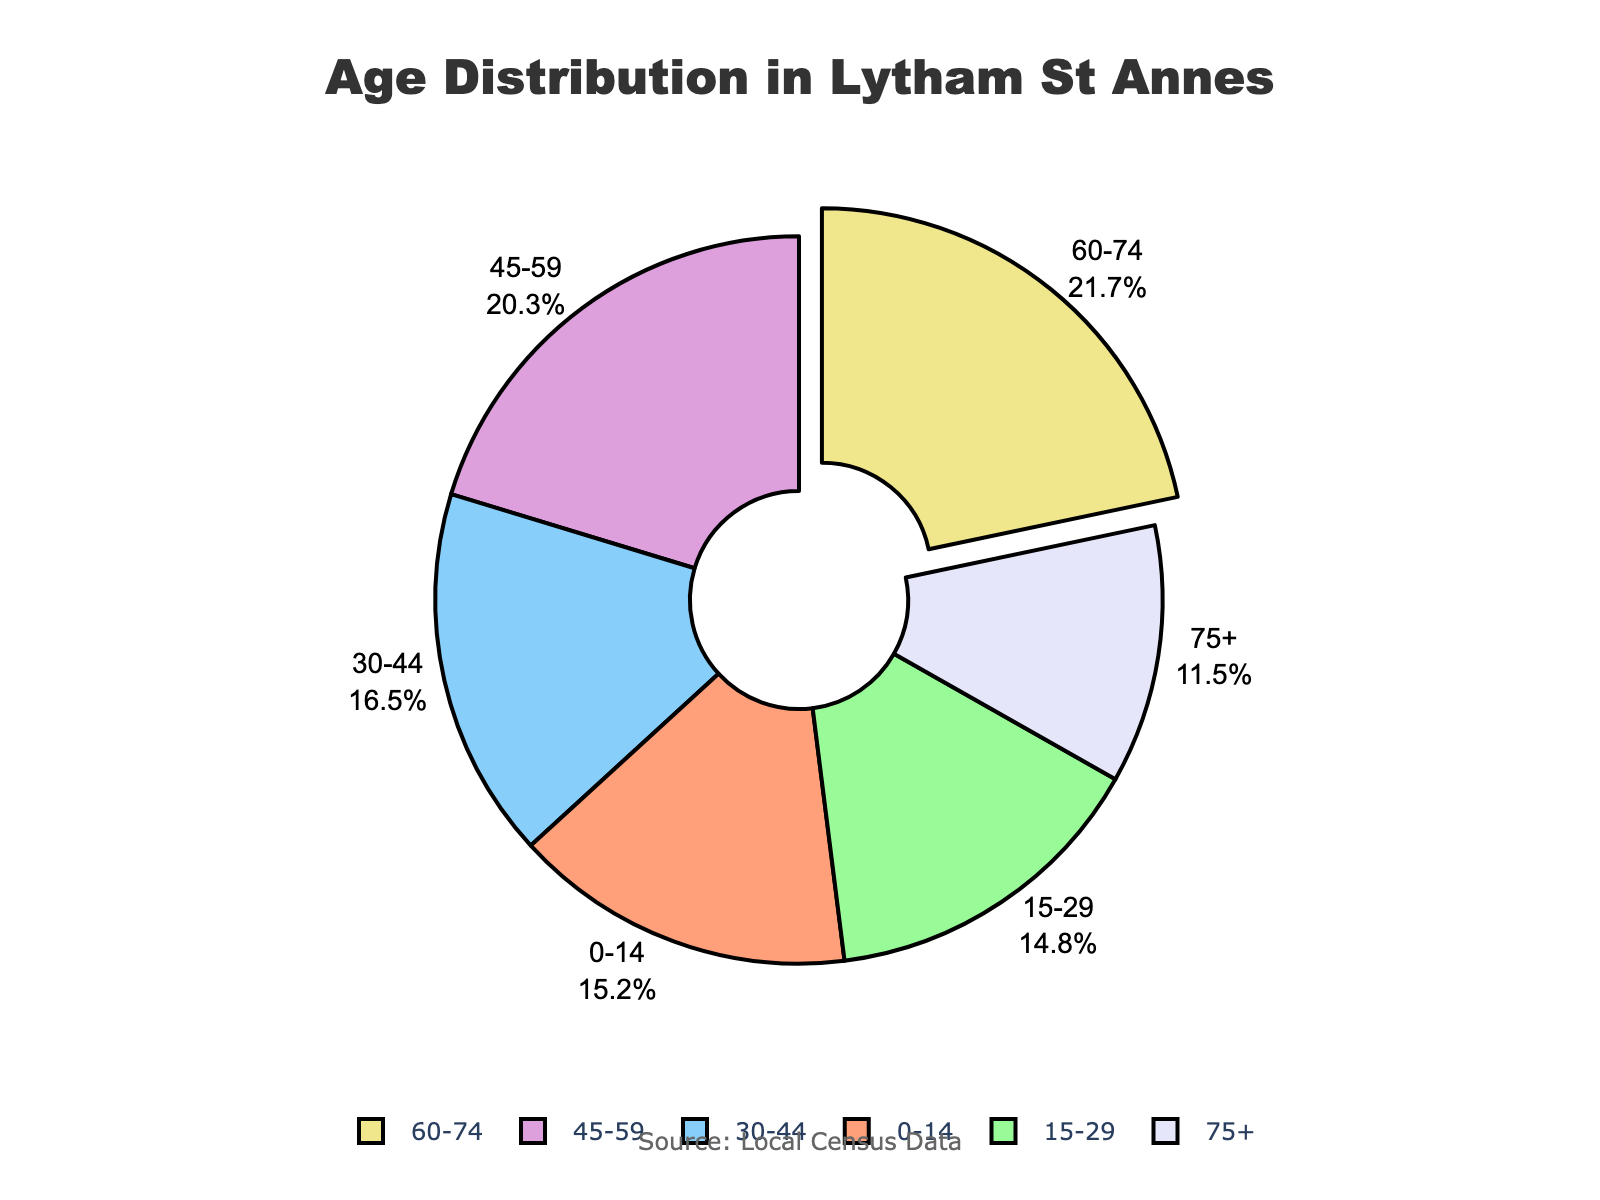What's the largest age group in Lytham St Annes? The largest slice of the pie chart represents the age group 60-74 at 21.7%.
Answer: 60-74 What's the difference in percentage between the youngest age group (0-14) and the oldest age group (75+)? The youngest age group (0-14) is 15.2%, and the oldest age group (75+) is 11.5%. Subtract the two percentages: 15.2 - 11.5 = 3.7.
Answer: 3.7% Which age groups together account for more than 40% of the population? The age groups 45-59 and 60-74 hold the largest percentages: 20.3% and 21.7% respectively. Together, they add up to 20.3 + 21.7 = 42%.
Answer: 45-59 and 60-74 Which age group has the smallest proportion in the population? The annotation and labels indicate that the smallest slice, 11.5%, corresponds to the age group 75+.
Answer: 75+ What is the total percentage for the age groups under 30 years old? Add the percentages for the age groups 0-14 and 15-29: 15.2 + 14.8 = 30.
Answer: 30% What is the average percentage of the three youngest age groups? The percentages for the three youngest age groups are 15.2%, 14.8%, and 16.5%. Sum them up: 15.2 + 14.8 + 16.5 = 46.5. Divide by 3: 46.5 / 3 = 15.5.
Answer: 15.5% Is the percentage of the age group 30-44 greater than the percentage of the age group 75+? The pie chart shows that 30-44 is 16.5%, and 75+ is 11.5%. Since 16.5 > 11.5, the age group 30-44 has a higher percentage.
Answer: Yes Which two age groups have the closest percentage values? The pie chart shows that the 0-14 age group is at 15.2% and the 15-29 age group is at 14.8%. The difference is 15.2 - 14.8 = 0.4, the smallest among all.
Answer: 0-14 and 15-29 